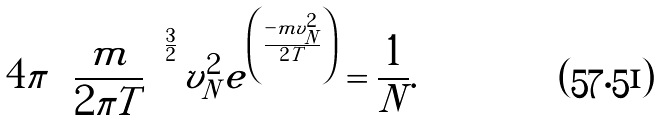<formula> <loc_0><loc_0><loc_500><loc_500>4 \pi \left ( \frac { m } { 2 \pi T } \right ) ^ { \frac { 3 } { 2 } } v _ { N } ^ { 2 } e ^ { \left ( \frac { - m v _ { N } ^ { 2 } } { 2 T } \right ) } = \frac { 1 } { N } .</formula> 